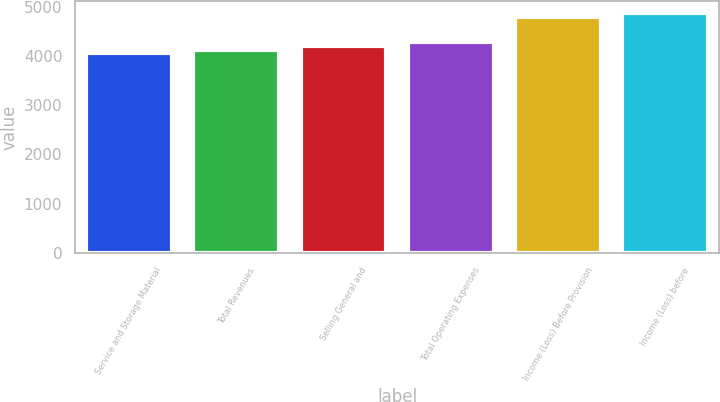Convert chart to OTSL. <chart><loc_0><loc_0><loc_500><loc_500><bar_chart><fcel>Service and Storage Material<fcel>Total Revenues<fcel>Selling General and<fcel>Total Operating Expenses<fcel>Income (Loss) Before Provision<fcel>Income (Loss) before<nl><fcel>4055<fcel>4129.4<fcel>4203.8<fcel>4278.2<fcel>4799<fcel>4873.4<nl></chart> 